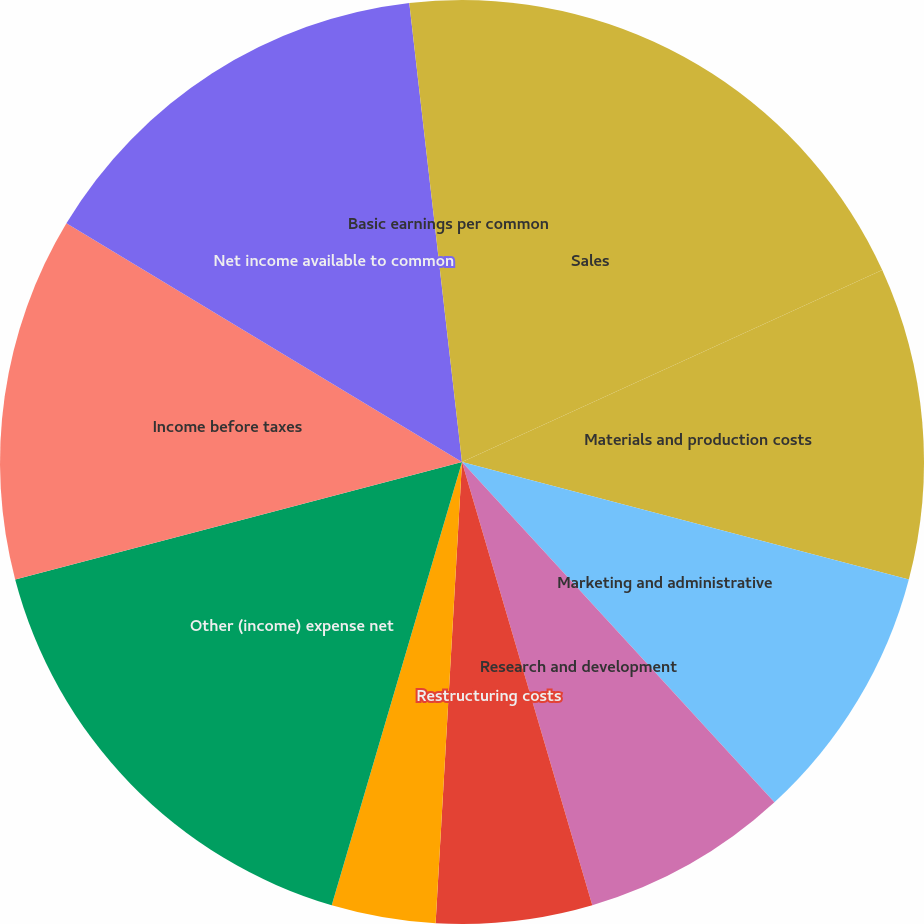<chart> <loc_0><loc_0><loc_500><loc_500><pie_chart><fcel>Sales<fcel>Materials and production costs<fcel>Marketing and administrative<fcel>Research and development<fcel>Restructuring costs<fcel>Equity income from affiliates<fcel>Other (income) expense net<fcel>Income before taxes<fcel>Net income available to common<fcel>Basic earnings per common<nl><fcel>18.18%<fcel>10.91%<fcel>9.09%<fcel>7.27%<fcel>5.46%<fcel>3.64%<fcel>16.36%<fcel>12.73%<fcel>14.54%<fcel>1.82%<nl></chart> 